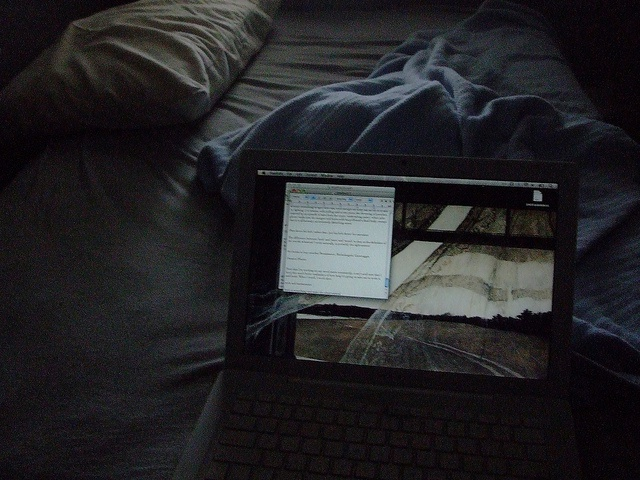Describe the objects in this image and their specific colors. I can see bed in black, gray, and darkblue tones and laptop in black, darkgray, and gray tones in this image. 